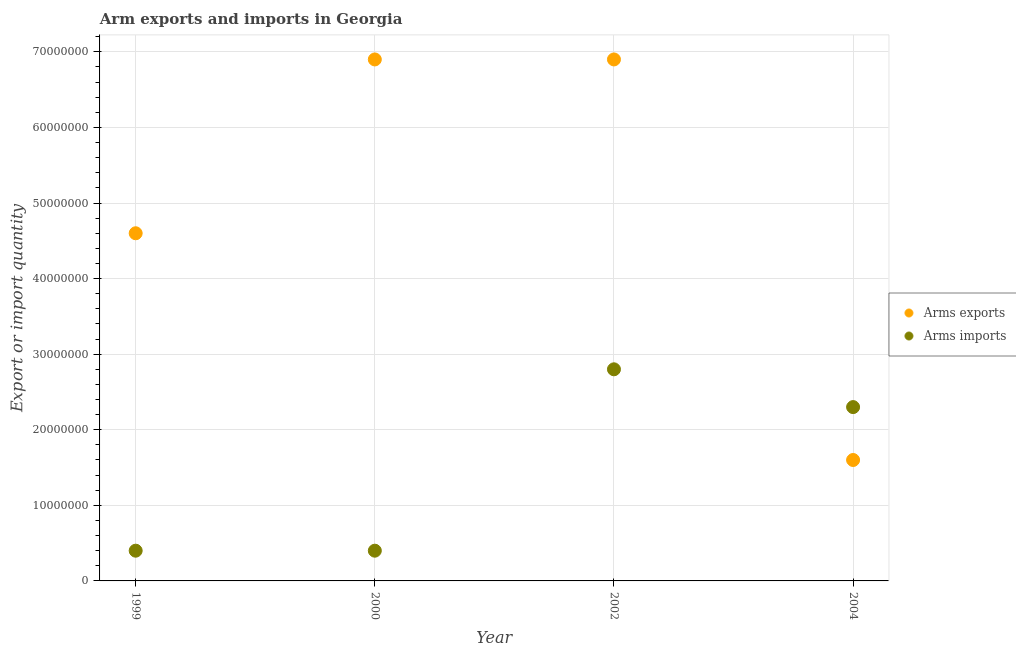What is the arms exports in 1999?
Offer a terse response. 4.60e+07. Across all years, what is the maximum arms imports?
Make the answer very short. 2.80e+07. Across all years, what is the minimum arms imports?
Offer a very short reply. 4.00e+06. In which year was the arms imports maximum?
Keep it short and to the point. 2002. In which year was the arms exports minimum?
Your answer should be very brief. 2004. What is the total arms exports in the graph?
Provide a short and direct response. 2.00e+08. What is the difference between the arms imports in 2000 and that in 2004?
Provide a succinct answer. -1.90e+07. What is the difference between the arms exports in 1999 and the arms imports in 2000?
Offer a terse response. 4.20e+07. What is the average arms exports per year?
Provide a succinct answer. 5.00e+07. In the year 2000, what is the difference between the arms imports and arms exports?
Provide a succinct answer. -6.50e+07. What is the ratio of the arms imports in 1999 to that in 2004?
Make the answer very short. 0.17. Is the arms exports in 1999 less than that in 2000?
Offer a terse response. Yes. What is the difference between the highest and the second highest arms imports?
Your response must be concise. 5.00e+06. What is the difference between the highest and the lowest arms imports?
Offer a terse response. 2.40e+07. Is the sum of the arms imports in 1999 and 2004 greater than the maximum arms exports across all years?
Offer a terse response. No. Does the arms imports monotonically increase over the years?
Your answer should be compact. No. Is the arms exports strictly greater than the arms imports over the years?
Offer a very short reply. No. How many dotlines are there?
Your answer should be very brief. 2. How many years are there in the graph?
Provide a succinct answer. 4. What is the difference between two consecutive major ticks on the Y-axis?
Provide a short and direct response. 1.00e+07. Are the values on the major ticks of Y-axis written in scientific E-notation?
Provide a short and direct response. No. Does the graph contain any zero values?
Provide a succinct answer. No. Does the graph contain grids?
Your answer should be compact. Yes. What is the title of the graph?
Provide a succinct answer. Arm exports and imports in Georgia. Does "Private consumption" appear as one of the legend labels in the graph?
Your response must be concise. No. What is the label or title of the Y-axis?
Ensure brevity in your answer.  Export or import quantity. What is the Export or import quantity of Arms exports in 1999?
Offer a terse response. 4.60e+07. What is the Export or import quantity of Arms exports in 2000?
Your answer should be compact. 6.90e+07. What is the Export or import quantity in Arms imports in 2000?
Provide a succinct answer. 4.00e+06. What is the Export or import quantity in Arms exports in 2002?
Ensure brevity in your answer.  6.90e+07. What is the Export or import quantity of Arms imports in 2002?
Offer a very short reply. 2.80e+07. What is the Export or import quantity in Arms exports in 2004?
Offer a terse response. 1.60e+07. What is the Export or import quantity in Arms imports in 2004?
Make the answer very short. 2.30e+07. Across all years, what is the maximum Export or import quantity in Arms exports?
Your answer should be compact. 6.90e+07. Across all years, what is the maximum Export or import quantity of Arms imports?
Give a very brief answer. 2.80e+07. Across all years, what is the minimum Export or import quantity in Arms exports?
Your answer should be compact. 1.60e+07. What is the total Export or import quantity in Arms imports in the graph?
Give a very brief answer. 5.90e+07. What is the difference between the Export or import quantity in Arms exports in 1999 and that in 2000?
Your answer should be very brief. -2.30e+07. What is the difference between the Export or import quantity of Arms exports in 1999 and that in 2002?
Give a very brief answer. -2.30e+07. What is the difference between the Export or import quantity of Arms imports in 1999 and that in 2002?
Your response must be concise. -2.40e+07. What is the difference between the Export or import quantity of Arms exports in 1999 and that in 2004?
Keep it short and to the point. 3.00e+07. What is the difference between the Export or import quantity of Arms imports in 1999 and that in 2004?
Your answer should be compact. -1.90e+07. What is the difference between the Export or import quantity in Arms imports in 2000 and that in 2002?
Offer a terse response. -2.40e+07. What is the difference between the Export or import quantity in Arms exports in 2000 and that in 2004?
Provide a succinct answer. 5.30e+07. What is the difference between the Export or import quantity of Arms imports in 2000 and that in 2004?
Make the answer very short. -1.90e+07. What is the difference between the Export or import quantity in Arms exports in 2002 and that in 2004?
Your answer should be compact. 5.30e+07. What is the difference between the Export or import quantity of Arms imports in 2002 and that in 2004?
Keep it short and to the point. 5.00e+06. What is the difference between the Export or import quantity in Arms exports in 1999 and the Export or import quantity in Arms imports in 2000?
Provide a short and direct response. 4.20e+07. What is the difference between the Export or import quantity in Arms exports in 1999 and the Export or import quantity in Arms imports in 2002?
Your response must be concise. 1.80e+07. What is the difference between the Export or import quantity in Arms exports in 1999 and the Export or import quantity in Arms imports in 2004?
Your answer should be very brief. 2.30e+07. What is the difference between the Export or import quantity of Arms exports in 2000 and the Export or import quantity of Arms imports in 2002?
Ensure brevity in your answer.  4.10e+07. What is the difference between the Export or import quantity of Arms exports in 2000 and the Export or import quantity of Arms imports in 2004?
Give a very brief answer. 4.60e+07. What is the difference between the Export or import quantity in Arms exports in 2002 and the Export or import quantity in Arms imports in 2004?
Offer a very short reply. 4.60e+07. What is the average Export or import quantity of Arms exports per year?
Keep it short and to the point. 5.00e+07. What is the average Export or import quantity of Arms imports per year?
Offer a very short reply. 1.48e+07. In the year 1999, what is the difference between the Export or import quantity in Arms exports and Export or import quantity in Arms imports?
Your answer should be very brief. 4.20e+07. In the year 2000, what is the difference between the Export or import quantity of Arms exports and Export or import quantity of Arms imports?
Your response must be concise. 6.50e+07. In the year 2002, what is the difference between the Export or import quantity in Arms exports and Export or import quantity in Arms imports?
Give a very brief answer. 4.10e+07. In the year 2004, what is the difference between the Export or import quantity in Arms exports and Export or import quantity in Arms imports?
Your response must be concise. -7.00e+06. What is the ratio of the Export or import quantity of Arms exports in 1999 to that in 2002?
Make the answer very short. 0.67. What is the ratio of the Export or import quantity of Arms imports in 1999 to that in 2002?
Keep it short and to the point. 0.14. What is the ratio of the Export or import quantity in Arms exports in 1999 to that in 2004?
Ensure brevity in your answer.  2.88. What is the ratio of the Export or import quantity of Arms imports in 1999 to that in 2004?
Provide a short and direct response. 0.17. What is the ratio of the Export or import quantity of Arms imports in 2000 to that in 2002?
Offer a very short reply. 0.14. What is the ratio of the Export or import quantity in Arms exports in 2000 to that in 2004?
Your response must be concise. 4.31. What is the ratio of the Export or import quantity of Arms imports in 2000 to that in 2004?
Offer a terse response. 0.17. What is the ratio of the Export or import quantity of Arms exports in 2002 to that in 2004?
Provide a short and direct response. 4.31. What is the ratio of the Export or import quantity of Arms imports in 2002 to that in 2004?
Give a very brief answer. 1.22. What is the difference between the highest and the second highest Export or import quantity in Arms exports?
Keep it short and to the point. 0. What is the difference between the highest and the second highest Export or import quantity in Arms imports?
Provide a short and direct response. 5.00e+06. What is the difference between the highest and the lowest Export or import quantity of Arms exports?
Provide a succinct answer. 5.30e+07. What is the difference between the highest and the lowest Export or import quantity of Arms imports?
Your response must be concise. 2.40e+07. 